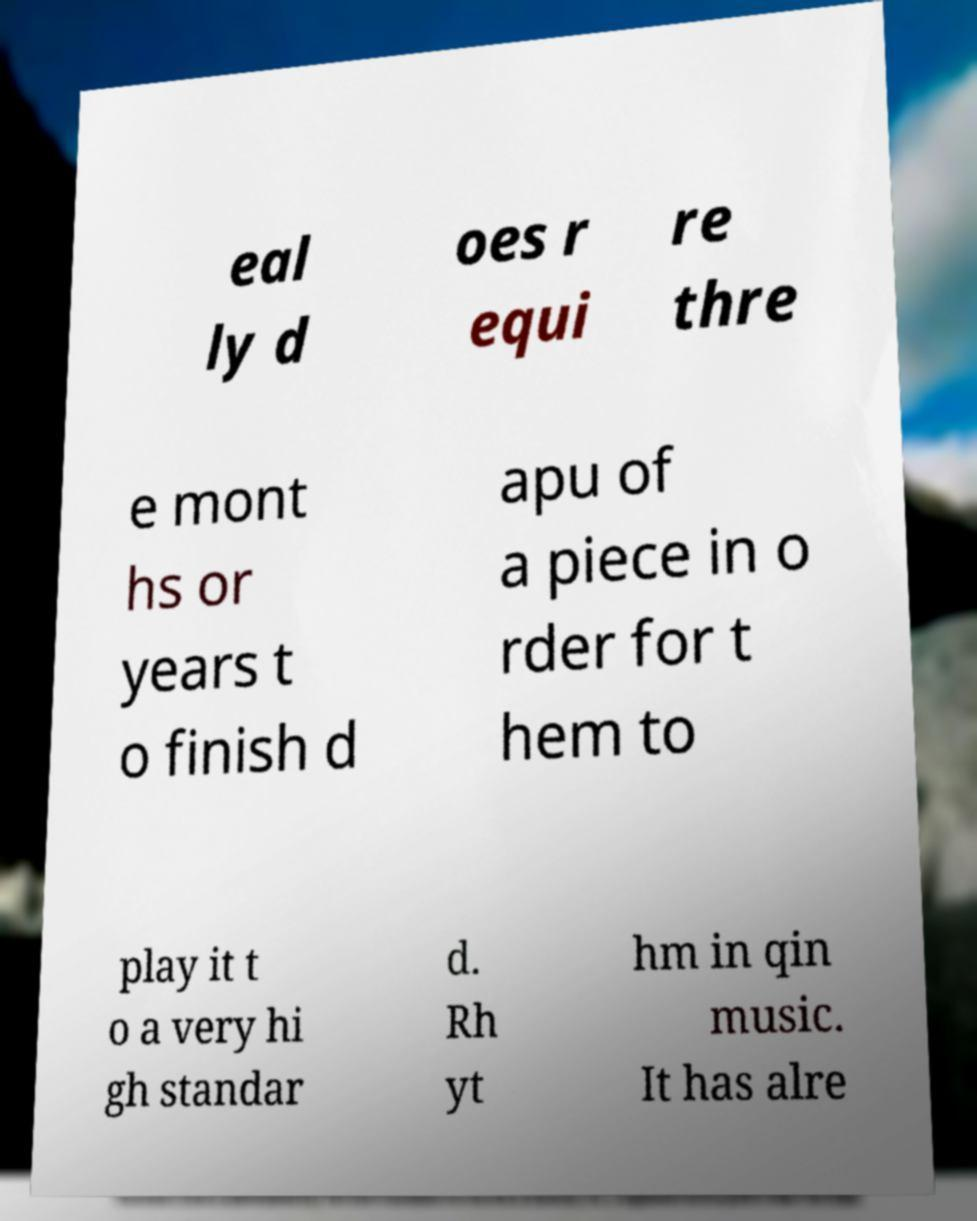Could you extract and type out the text from this image? eal ly d oes r equi re thre e mont hs or years t o finish d apu of a piece in o rder for t hem to play it t o a very hi gh standar d. Rh yt hm in qin music. It has alre 